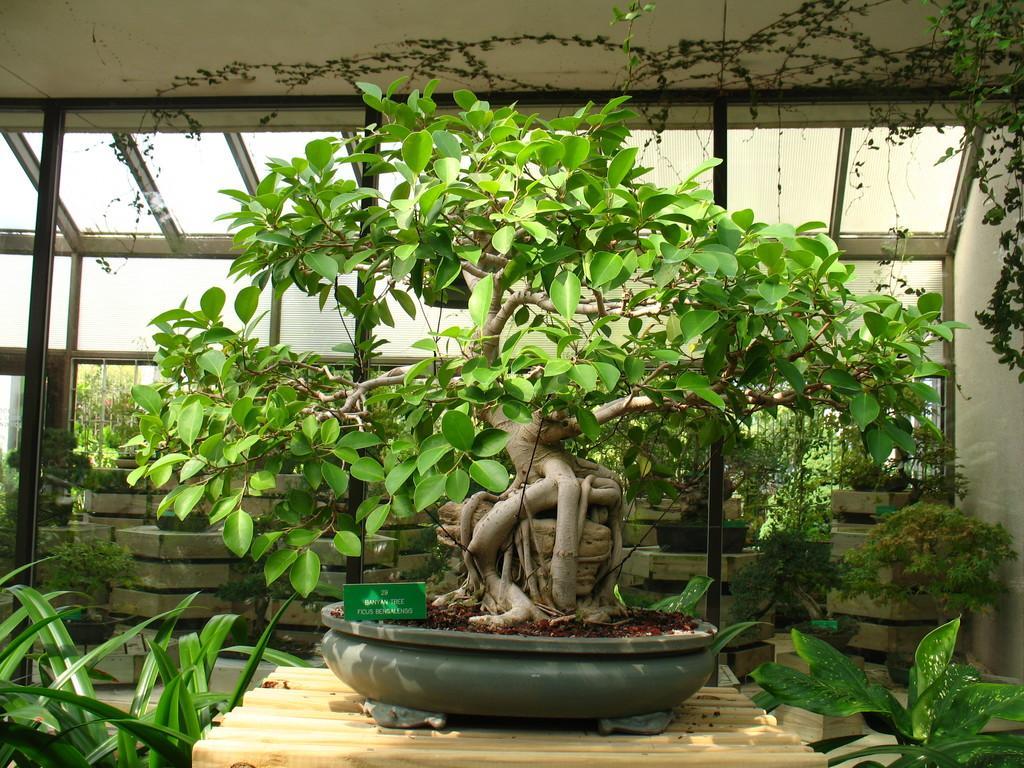Could you give a brief overview of what you see in this image? In this image we can see the flower pots. We can also see the text boards, table, grass and also the glass windows. We can also see the ceiling. 